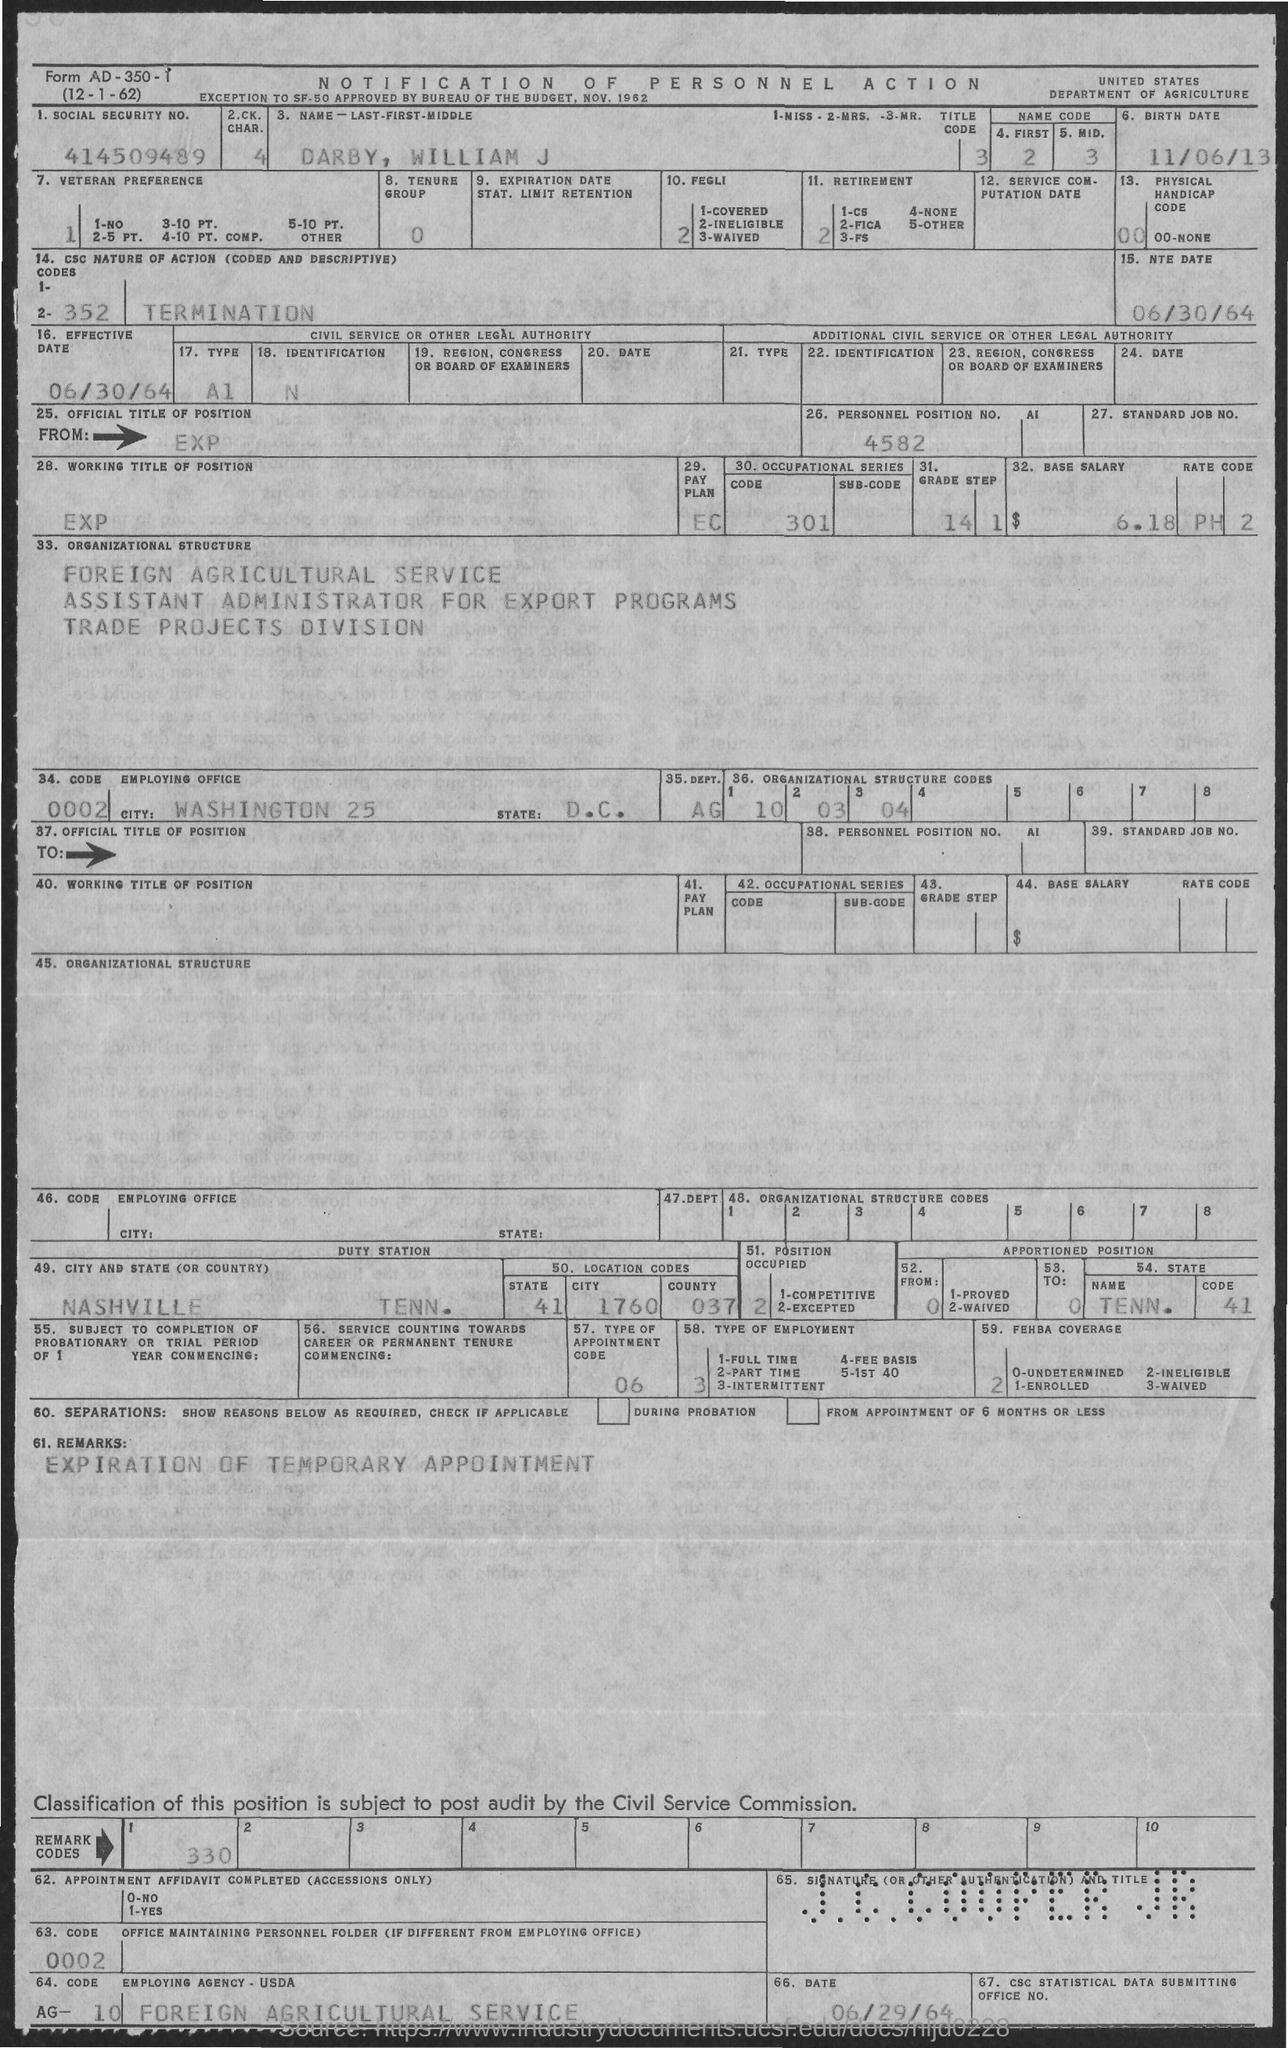What is the Social Security No. given in the document?
Keep it short and to the point. 414509489. What is the name of the person given in the document?
Offer a terse response. Darby, William J. What is the birthdate of DARBY, WILLIAM J?
Give a very brief answer. 11/06/13. What is the Personal Position No. given in the document?
Your response must be concise. 4582. What is the employing agency of DARBY, WILLIAM J as per the document?
Your answer should be compact. FOREIGN AGRICULTURAL SERVICE. What is the NTE Date given in the document?
Your answer should be very brief. 06/30/64. What is the base salary of DARBY, WILLIAM J mentioned in the document?
Provide a succinct answer. $ 6.18. 